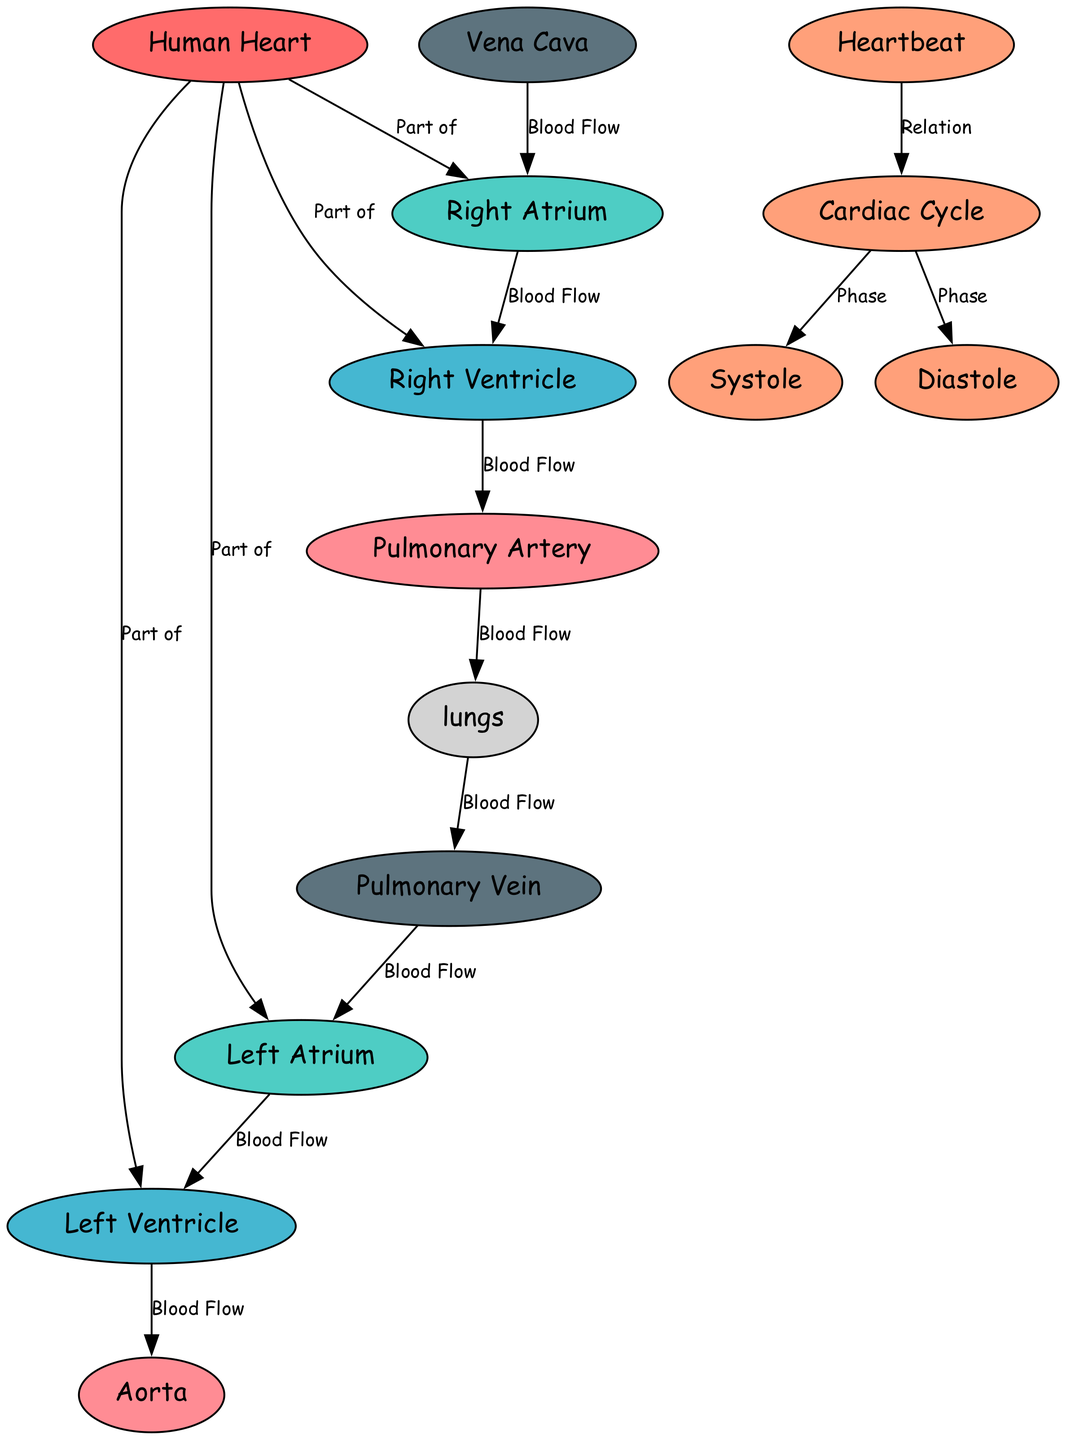What is the main organ depicted in the diagram? The diagram's central node labeled "Human Heart" clearly identifies it as the main organ of the cardiovascular system.
Answer: Human Heart How many chambers does the heart have? By examining the nodes in the diagram, there are four that correspond to the heart's chambers: left atrium, left ventricle, right atrium, and right ventricle.
Answer: Four What is the function of the left ventricle? The diagram describes the left ventricle specifically as the part that pumps oxygenated blood to the body, indicating its crucial role in circulation.
Answer: Pumps oxygenated blood to the body Which node represents the major artery? The node labeled "Aorta" in the diagram indicates it as the major artery responsible for distributing oxygenated blood from the heart.
Answer: Aorta What flows from the right atrium to the right ventricle? The edge connecting the right atrium to the right ventricle in the diagram is labeled "Blood Flow," which suggests that deoxygenated blood flows from one to the other.
Answer: Deoxygenated blood What is the relationship between the heartbeat and cardiac cycle? The diagram illustrates that the "Heartbeat" is composed of multiple "cardiac cycles," showing how these two terms are interconnected in the function of the heart.
Answer: Heartbeat is composed of cardiac cycles During which phase do the heart muscles contract? According to the diagram, "Systole" is identified as the contraction phase within the sequence of events during the cardiac cycle, thus answering the question.
Answer: Systole How does oxygenated blood return to the heart? The diagram indicates that oxygenated blood returns to the heart through the "Pulmonary Vein," which connects the lungs back to the heart.
Answer: Pulmonary Vein Which node connects deoxygenated blood from the body into the heart? The node "Vena Cava" is specifically labeled as the major vein carrying deoxygenated blood into the right atrium of the heart, fulfilling this function.
Answer: Vena Cava 